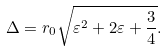<formula> <loc_0><loc_0><loc_500><loc_500>\Delta = r _ { 0 } \sqrt { \varepsilon ^ { 2 } + 2 \varepsilon + \frac { 3 } { 4 } } .</formula> 